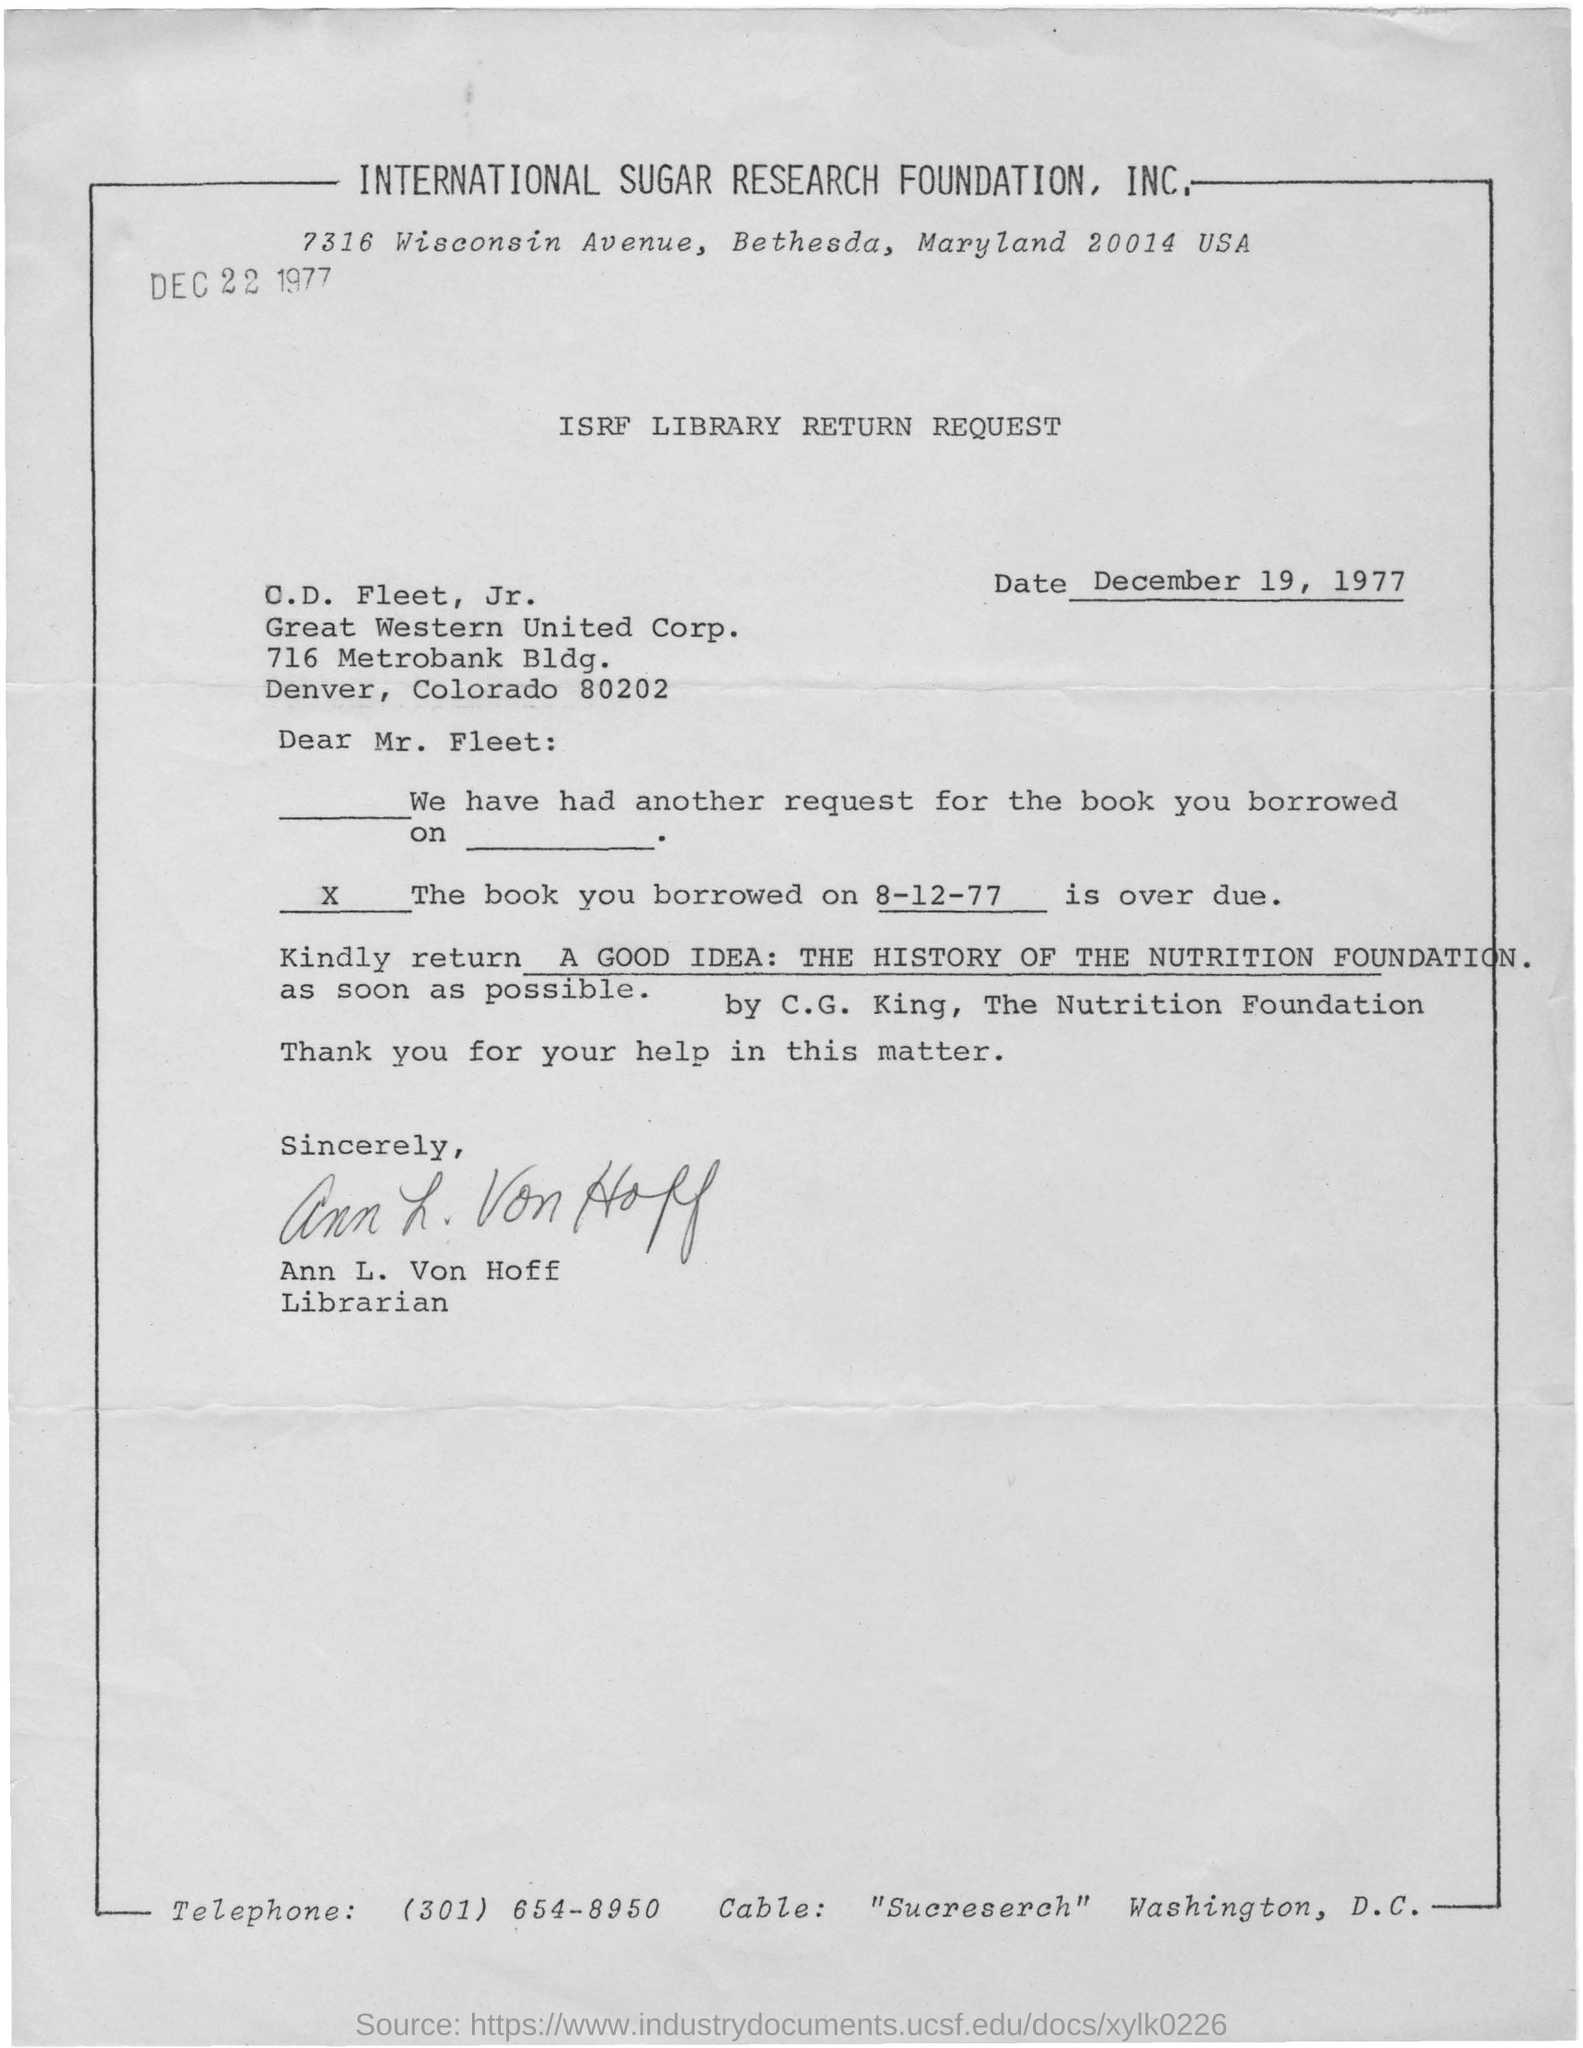What is the address of international sugar research foundation, inc.?
Provide a succinct answer. 7316 Wisconsin avenue, Bethesda, Maryland 20014 USA. When is the letter dated on ?
Keep it short and to the point. December 19, 1977. Who is writing letter to c.d. fleet?
Provide a short and direct response. Ann l. von hoff. What is the telephone number given at the bottom of letter?
Give a very brief answer. (301) 654-8950. 